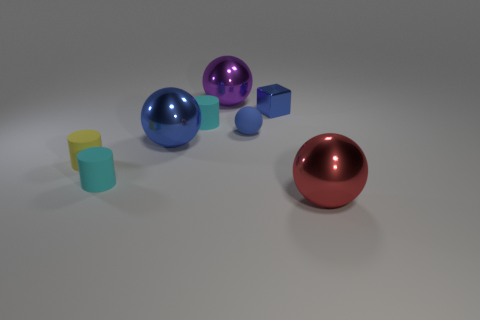Are there any tiny cyan objects that have the same material as the large blue sphere?
Provide a succinct answer. No. There is a thing that is in front of the tiny yellow rubber object and behind the red metal thing; what is its shape?
Your response must be concise. Cylinder. What number of other objects are there of the same shape as the big blue shiny object?
Provide a succinct answer. 3. The block is what size?
Your answer should be compact. Small. How many things are small shiny things or blue things?
Make the answer very short. 3. How big is the metallic object to the right of the shiny block?
Your response must be concise. Large. What color is the object that is both on the left side of the big purple ball and behind the large blue sphere?
Your answer should be compact. Cyan. Is the cylinder behind the small rubber ball made of the same material as the purple object?
Keep it short and to the point. No. Is the color of the shiny cube the same as the small rubber sphere right of the yellow matte cylinder?
Provide a short and direct response. Yes. There is a cube; are there any large metal spheres right of it?
Give a very brief answer. Yes. 